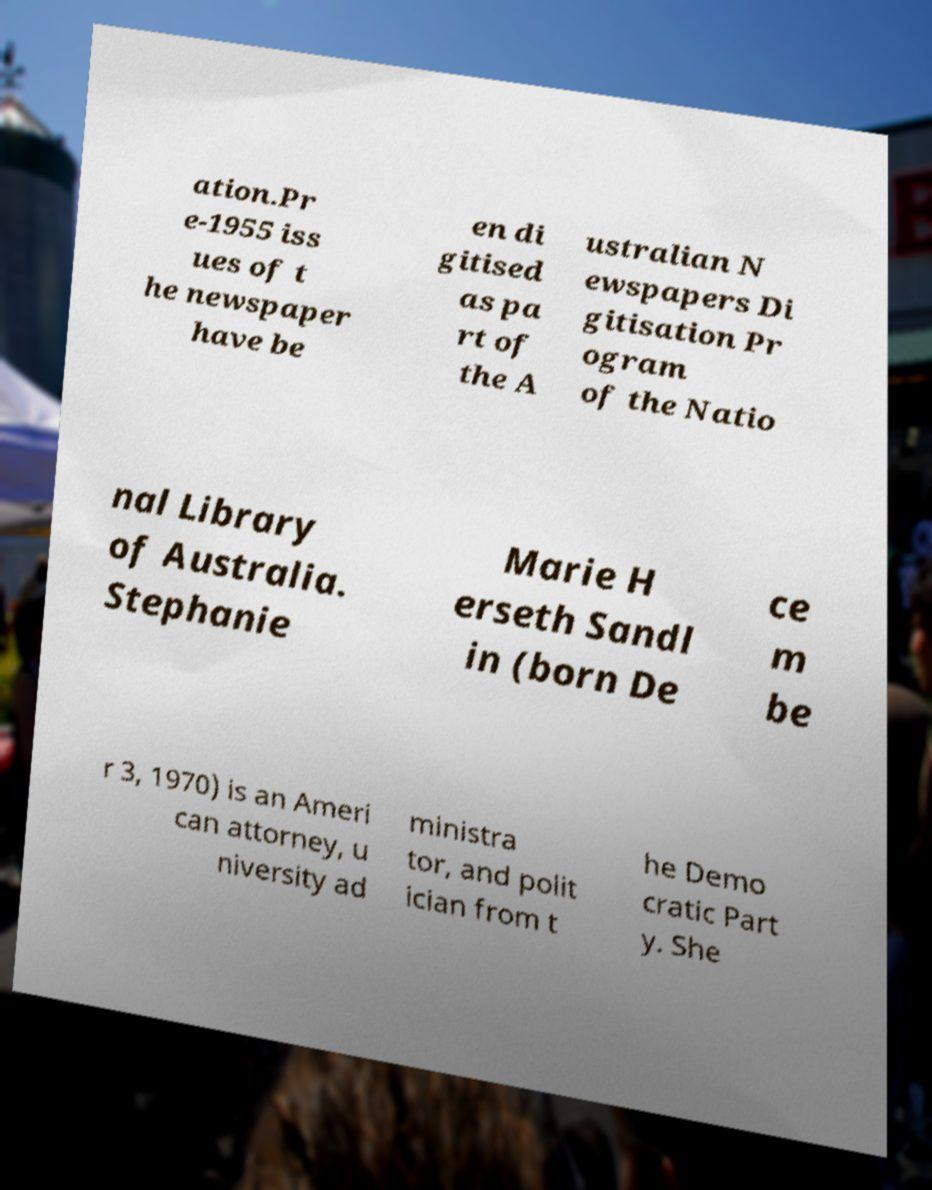Can you accurately transcribe the text from the provided image for me? ation.Pr e-1955 iss ues of t he newspaper have be en di gitised as pa rt of the A ustralian N ewspapers Di gitisation Pr ogram of the Natio nal Library of Australia. Stephanie Marie H erseth Sandl in (born De ce m be r 3, 1970) is an Ameri can attorney, u niversity ad ministra tor, and polit ician from t he Demo cratic Part y. She 